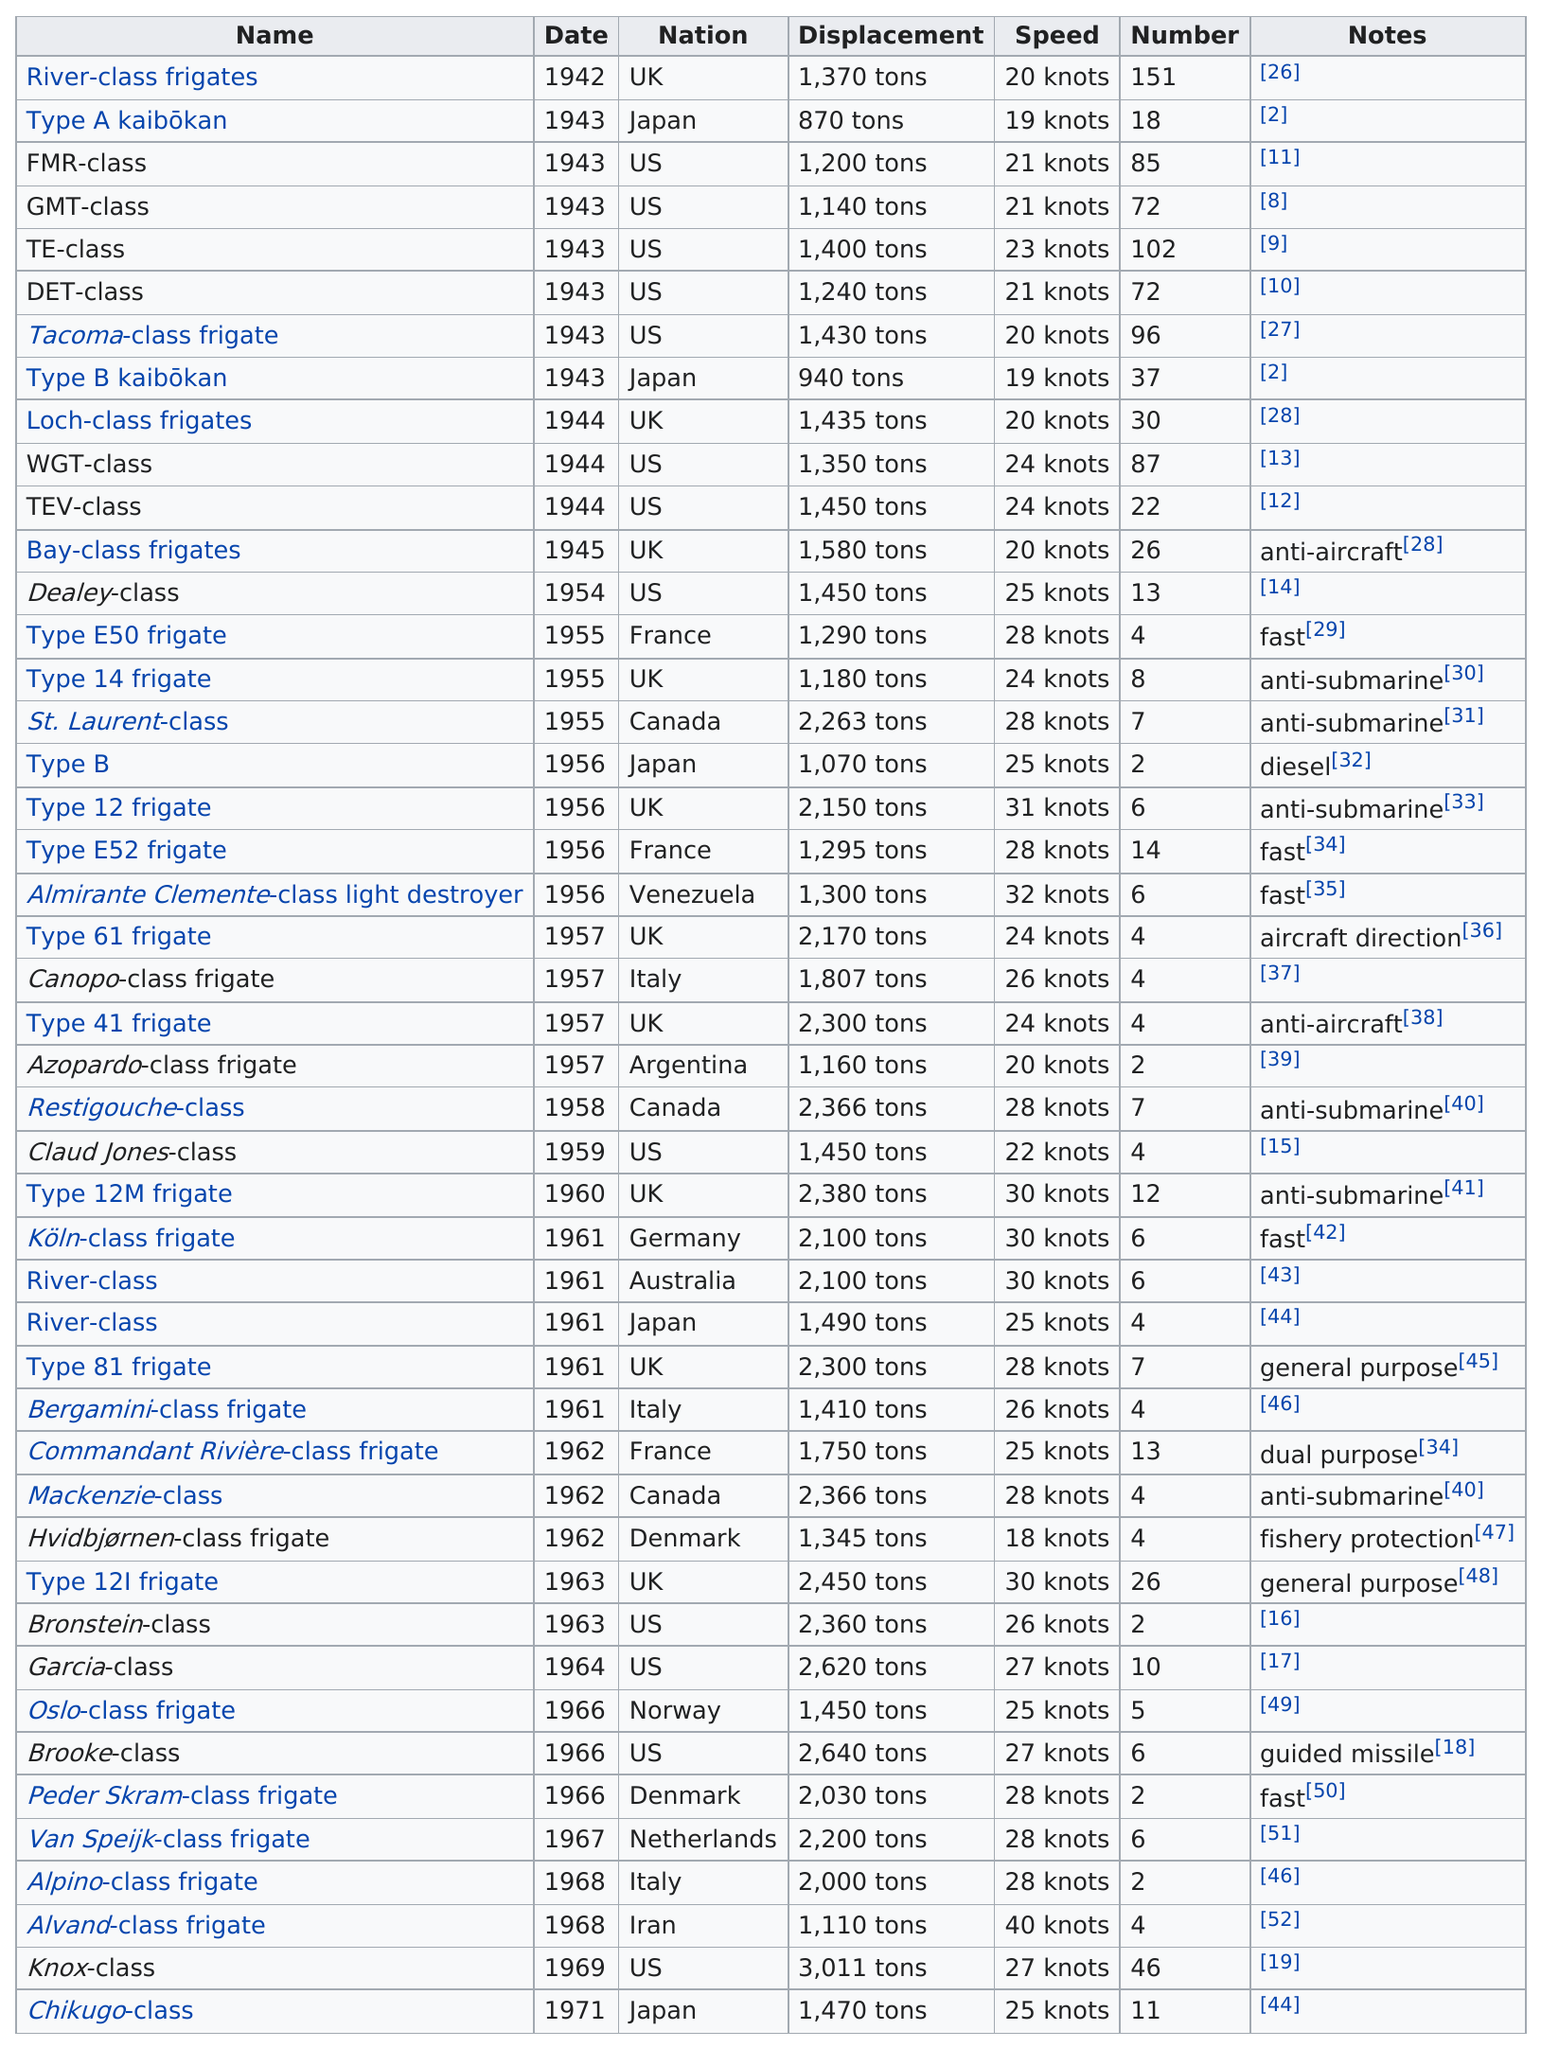Point out several critical features in this image. The Alvand-class frigate is the fastest of the boats listed. The displacement of Type B is 940 tons. In 1968, the Italian Navy utilized an Alpino-class frigate, which had a top speed of 28 knots. The top speed is 40 knots. The speed difference between the GMT-class and the TE-class is approximately 2 knots. 